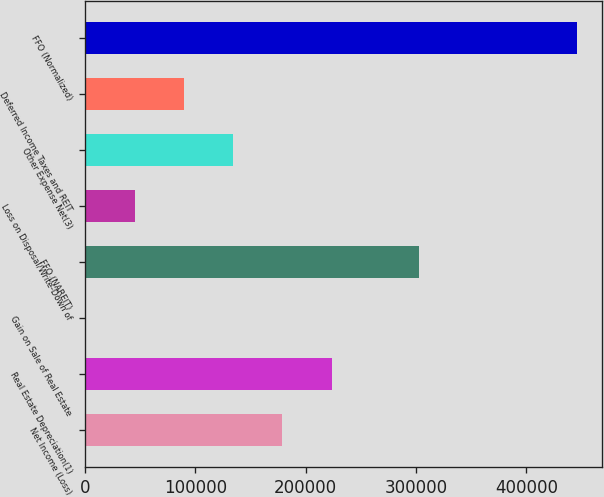<chart> <loc_0><loc_0><loc_500><loc_500><bar_chart><fcel>Net Income (Loss)<fcel>Real Estate Depreciation(1)<fcel>Gain on Sale of Real Estate<fcel>FFO (NAREIT)<fcel>Loss on Disposal/Write-Down of<fcel>Other Expense Net(3)<fcel>Deferred Income Taxes and REIT<fcel>FFO (Normalized)<nl><fcel>179008<fcel>223547<fcel>850<fcel>303153<fcel>45389.4<fcel>134468<fcel>89928.8<fcel>446244<nl></chart> 